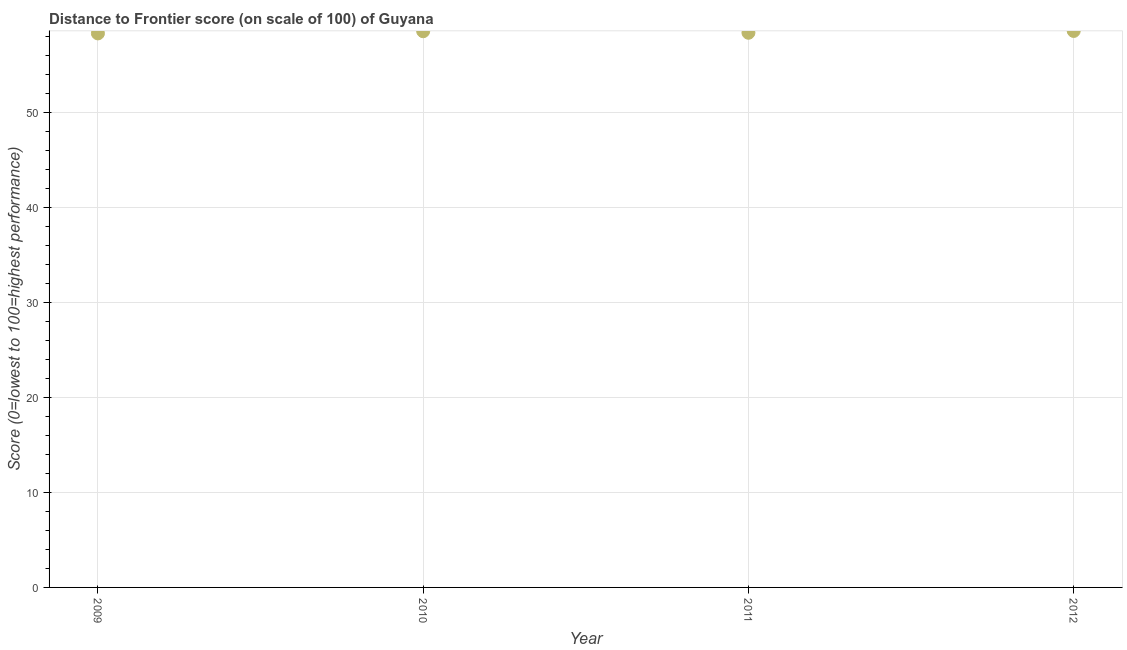What is the distance to frontier score in 2011?
Your answer should be very brief. 58.44. Across all years, what is the maximum distance to frontier score?
Give a very brief answer. 58.63. Across all years, what is the minimum distance to frontier score?
Your answer should be compact. 58.37. In which year was the distance to frontier score minimum?
Ensure brevity in your answer.  2009. What is the sum of the distance to frontier score?
Keep it short and to the point. 234.04. What is the difference between the distance to frontier score in 2009 and 2010?
Provide a succinct answer. -0.23. What is the average distance to frontier score per year?
Provide a succinct answer. 58.51. What is the median distance to frontier score?
Ensure brevity in your answer.  58.52. In how many years, is the distance to frontier score greater than 50 ?
Your answer should be very brief. 4. What is the ratio of the distance to frontier score in 2010 to that in 2012?
Provide a short and direct response. 1. Is the distance to frontier score in 2010 less than that in 2012?
Your answer should be very brief. Yes. Is the difference between the distance to frontier score in 2009 and 2011 greater than the difference between any two years?
Your response must be concise. No. What is the difference between the highest and the second highest distance to frontier score?
Provide a succinct answer. 0.03. What is the difference between the highest and the lowest distance to frontier score?
Your response must be concise. 0.26. In how many years, is the distance to frontier score greater than the average distance to frontier score taken over all years?
Keep it short and to the point. 2. How many dotlines are there?
Give a very brief answer. 1. Are the values on the major ticks of Y-axis written in scientific E-notation?
Offer a terse response. No. What is the title of the graph?
Provide a short and direct response. Distance to Frontier score (on scale of 100) of Guyana. What is the label or title of the Y-axis?
Make the answer very short. Score (0=lowest to 100=highest performance). What is the Score (0=lowest to 100=highest performance) in 2009?
Your answer should be compact. 58.37. What is the Score (0=lowest to 100=highest performance) in 2010?
Keep it short and to the point. 58.6. What is the Score (0=lowest to 100=highest performance) in 2011?
Your answer should be very brief. 58.44. What is the Score (0=lowest to 100=highest performance) in 2012?
Provide a short and direct response. 58.63. What is the difference between the Score (0=lowest to 100=highest performance) in 2009 and 2010?
Give a very brief answer. -0.23. What is the difference between the Score (0=lowest to 100=highest performance) in 2009 and 2011?
Your response must be concise. -0.07. What is the difference between the Score (0=lowest to 100=highest performance) in 2009 and 2012?
Make the answer very short. -0.26. What is the difference between the Score (0=lowest to 100=highest performance) in 2010 and 2011?
Provide a succinct answer. 0.16. What is the difference between the Score (0=lowest to 100=highest performance) in 2010 and 2012?
Offer a very short reply. -0.03. What is the difference between the Score (0=lowest to 100=highest performance) in 2011 and 2012?
Offer a very short reply. -0.19. What is the ratio of the Score (0=lowest to 100=highest performance) in 2009 to that in 2012?
Keep it short and to the point. 1. What is the ratio of the Score (0=lowest to 100=highest performance) in 2010 to that in 2011?
Ensure brevity in your answer.  1. What is the ratio of the Score (0=lowest to 100=highest performance) in 2010 to that in 2012?
Give a very brief answer. 1. What is the ratio of the Score (0=lowest to 100=highest performance) in 2011 to that in 2012?
Your answer should be very brief. 1. 